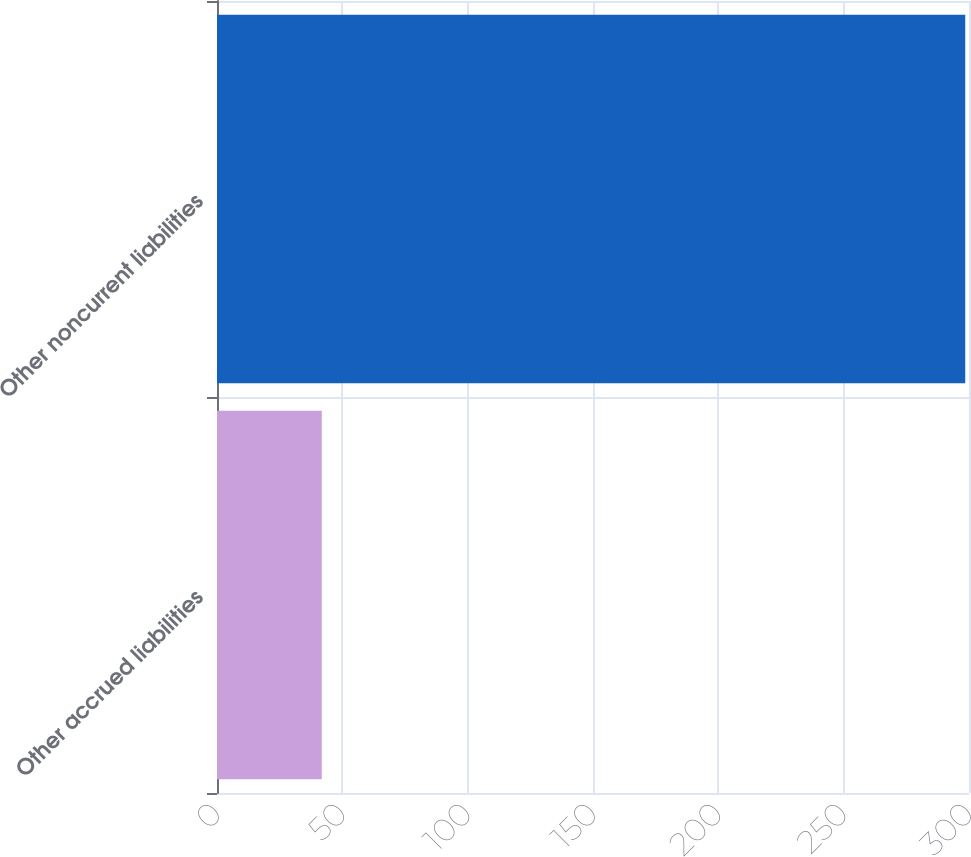Convert chart. <chart><loc_0><loc_0><loc_500><loc_500><bar_chart><fcel>Other accrued liabilities<fcel>Other noncurrent liabilities<nl><fcel>41.8<fcel>298.5<nl></chart> 